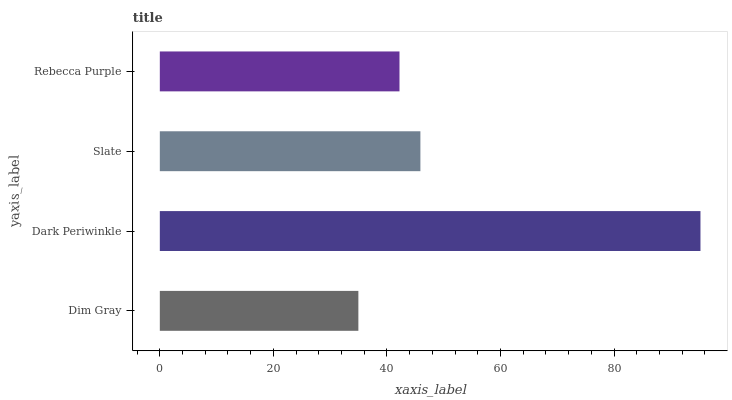Is Dim Gray the minimum?
Answer yes or no. Yes. Is Dark Periwinkle the maximum?
Answer yes or no. Yes. Is Slate the minimum?
Answer yes or no. No. Is Slate the maximum?
Answer yes or no. No. Is Dark Periwinkle greater than Slate?
Answer yes or no. Yes. Is Slate less than Dark Periwinkle?
Answer yes or no. Yes. Is Slate greater than Dark Periwinkle?
Answer yes or no. No. Is Dark Periwinkle less than Slate?
Answer yes or no. No. Is Slate the high median?
Answer yes or no. Yes. Is Rebecca Purple the low median?
Answer yes or no. Yes. Is Dark Periwinkle the high median?
Answer yes or no. No. Is Dim Gray the low median?
Answer yes or no. No. 